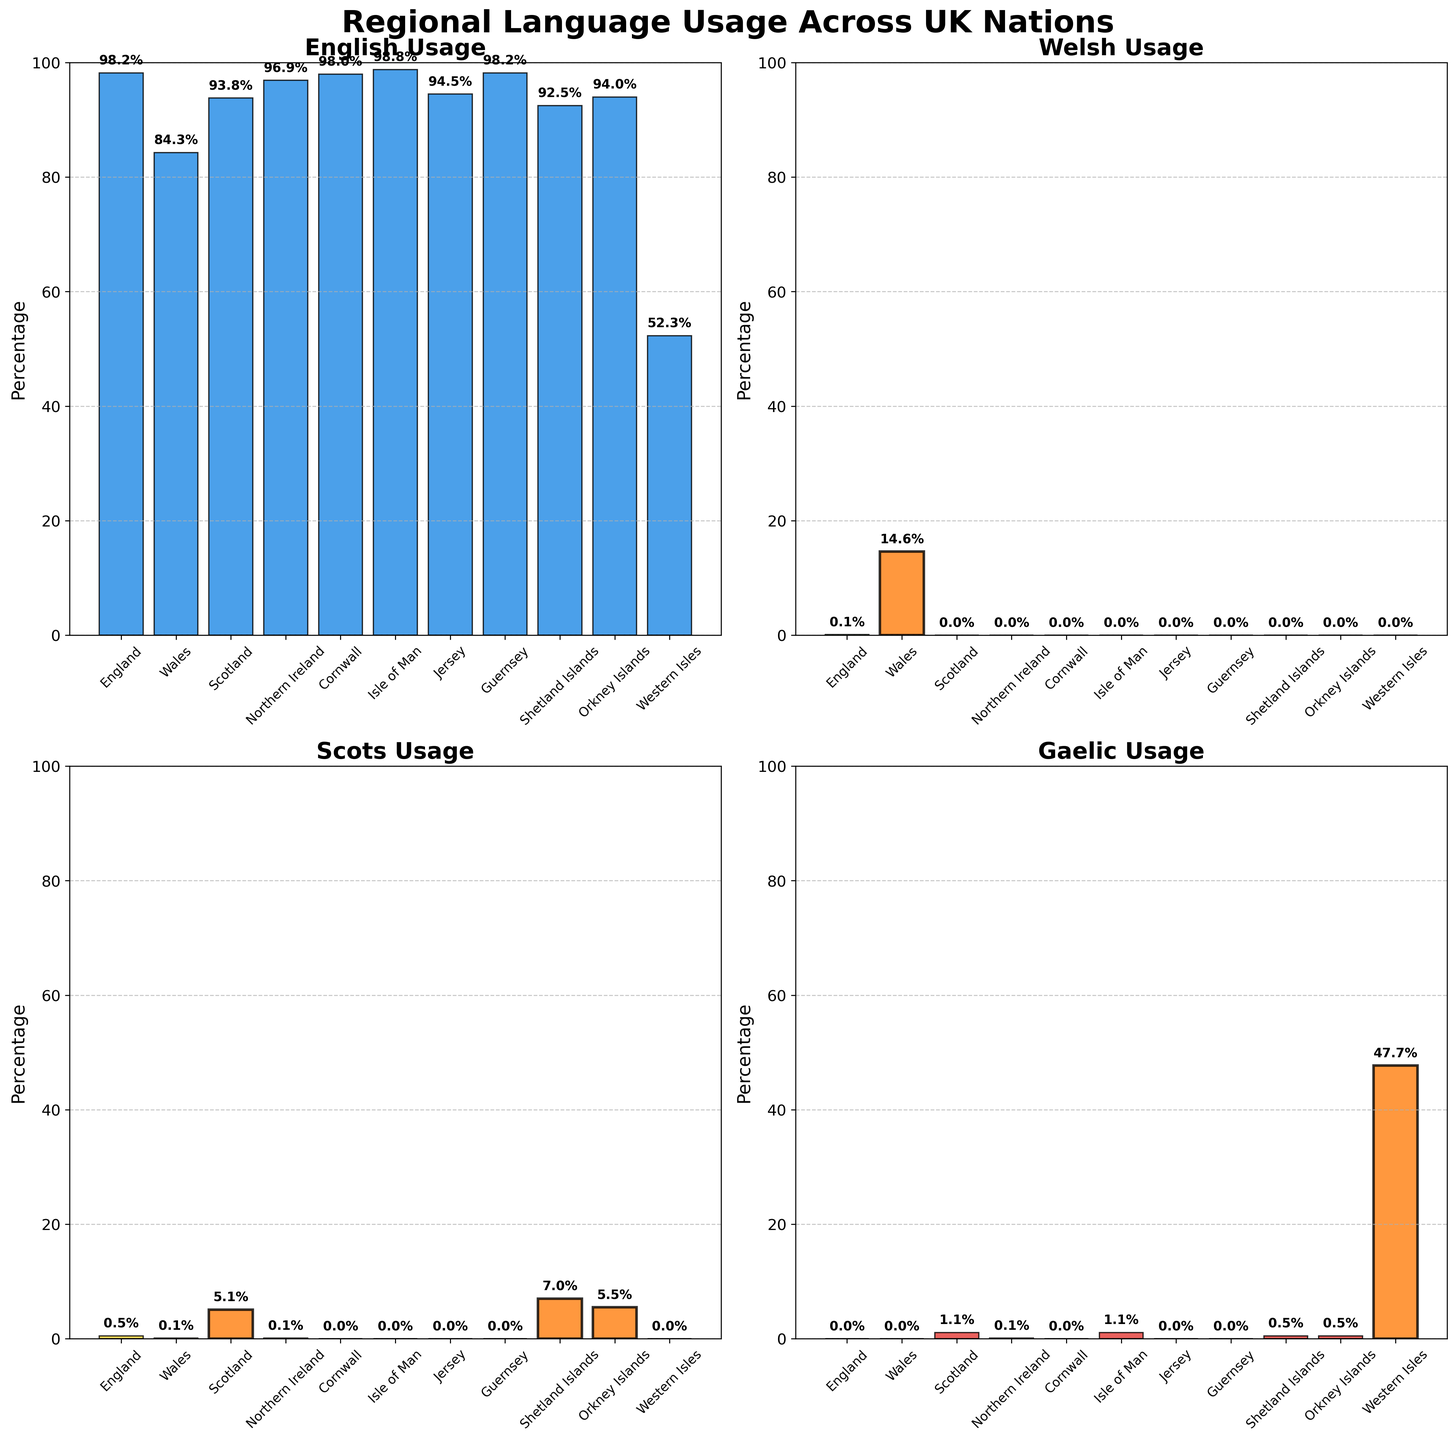Which nation has the highest usage of English? The "English Usage" subplot shows the percentage for each nation, and the Isle of Man has the highest usage at 98.8%.
Answer: Isle of Man Which nation has the highest percentage of Welsh speakers? The "Welsh Usage" subplot shows that Wales has the highest percentage at 14.6%.
Answer: Wales What is the combined percentage of Scots speakers in Scotland and the Shetland Islands? The "Scots Usage" subplot shows that Scotland has 5.1% and Shetland Islands have 7.0%. Adding these together gives 5.1 + 7.0 = 12.1%.
Answer: 12.1% Among the regions, which one has a notable usage of Gaelic and what is its percentage? The "Gaelic Usage" subplot shows that the Western Isles have a notable percentage of Gaelic speakers at 47.7%.
Answer: Western Isles In which nation does English usage appear less dominant compared to others, and what is its percentage? The "English Usage" subplot shows that the Western Isles have the lowest percentage at 52.3%.
Answer: Western Isles Which regions show highlighted bars for Scots usage, indicating significant levels? The "Scots Usage" subplot highlights bars for Scotland (5.1%), Shetland Islands (7.0%), and Orkney Islands (5.5%).
Answer: Scotland, Shetland Islands, Orkney Islands How many nations have a higher percentage of Welsh speakers than Scots speakers? The "Welsh Usage" subplot shows Wales has 14.6%, whereas the "Scots Usage" subplot shows that only Scotland, Shetland Islands, and Orkney Islands have Scots speakers. Since only Wales has a higher percentage of Welsh speakers, the count is 1.
Answer: 1 Which nation has the second highest percentage of Scots speakers after the Shetland Islands? The "Scots Usage" subplot shows that after Shetland Islands (7.0%), Orkney Islands have the second highest at 5.5%.
Answer: Orkney Islands What is the average usage of English across all nations? Adding all the percentages from the "English Usage" subplot (98.2 + 84.3 + 93.8 + 96.9 + 98.0 + 98.8 + 94.5 + 98.2 + 92.5 + 94.0 + 52.3) gives 1001.5. Dividing by the total number of regions (11) gives 1001.5/11 ≈ 91.0%.
Answer: 91.0% Which nation has the lowest percentage for both Welsh and Gaelic usage? The "Welsh Usage" subplot shows that all nations except Wales have 0.0% Welsh speakers. The "Gaelic Usage" subplot shows that all nations except Scotland, Isle of Man, and Western Isles have 0.0% Gaelic speakers. Among these, England, Cornwall, Jersey, and Guernsey fit the criteria.
Answer: England, Cornwall, Jersey, Guernsey 